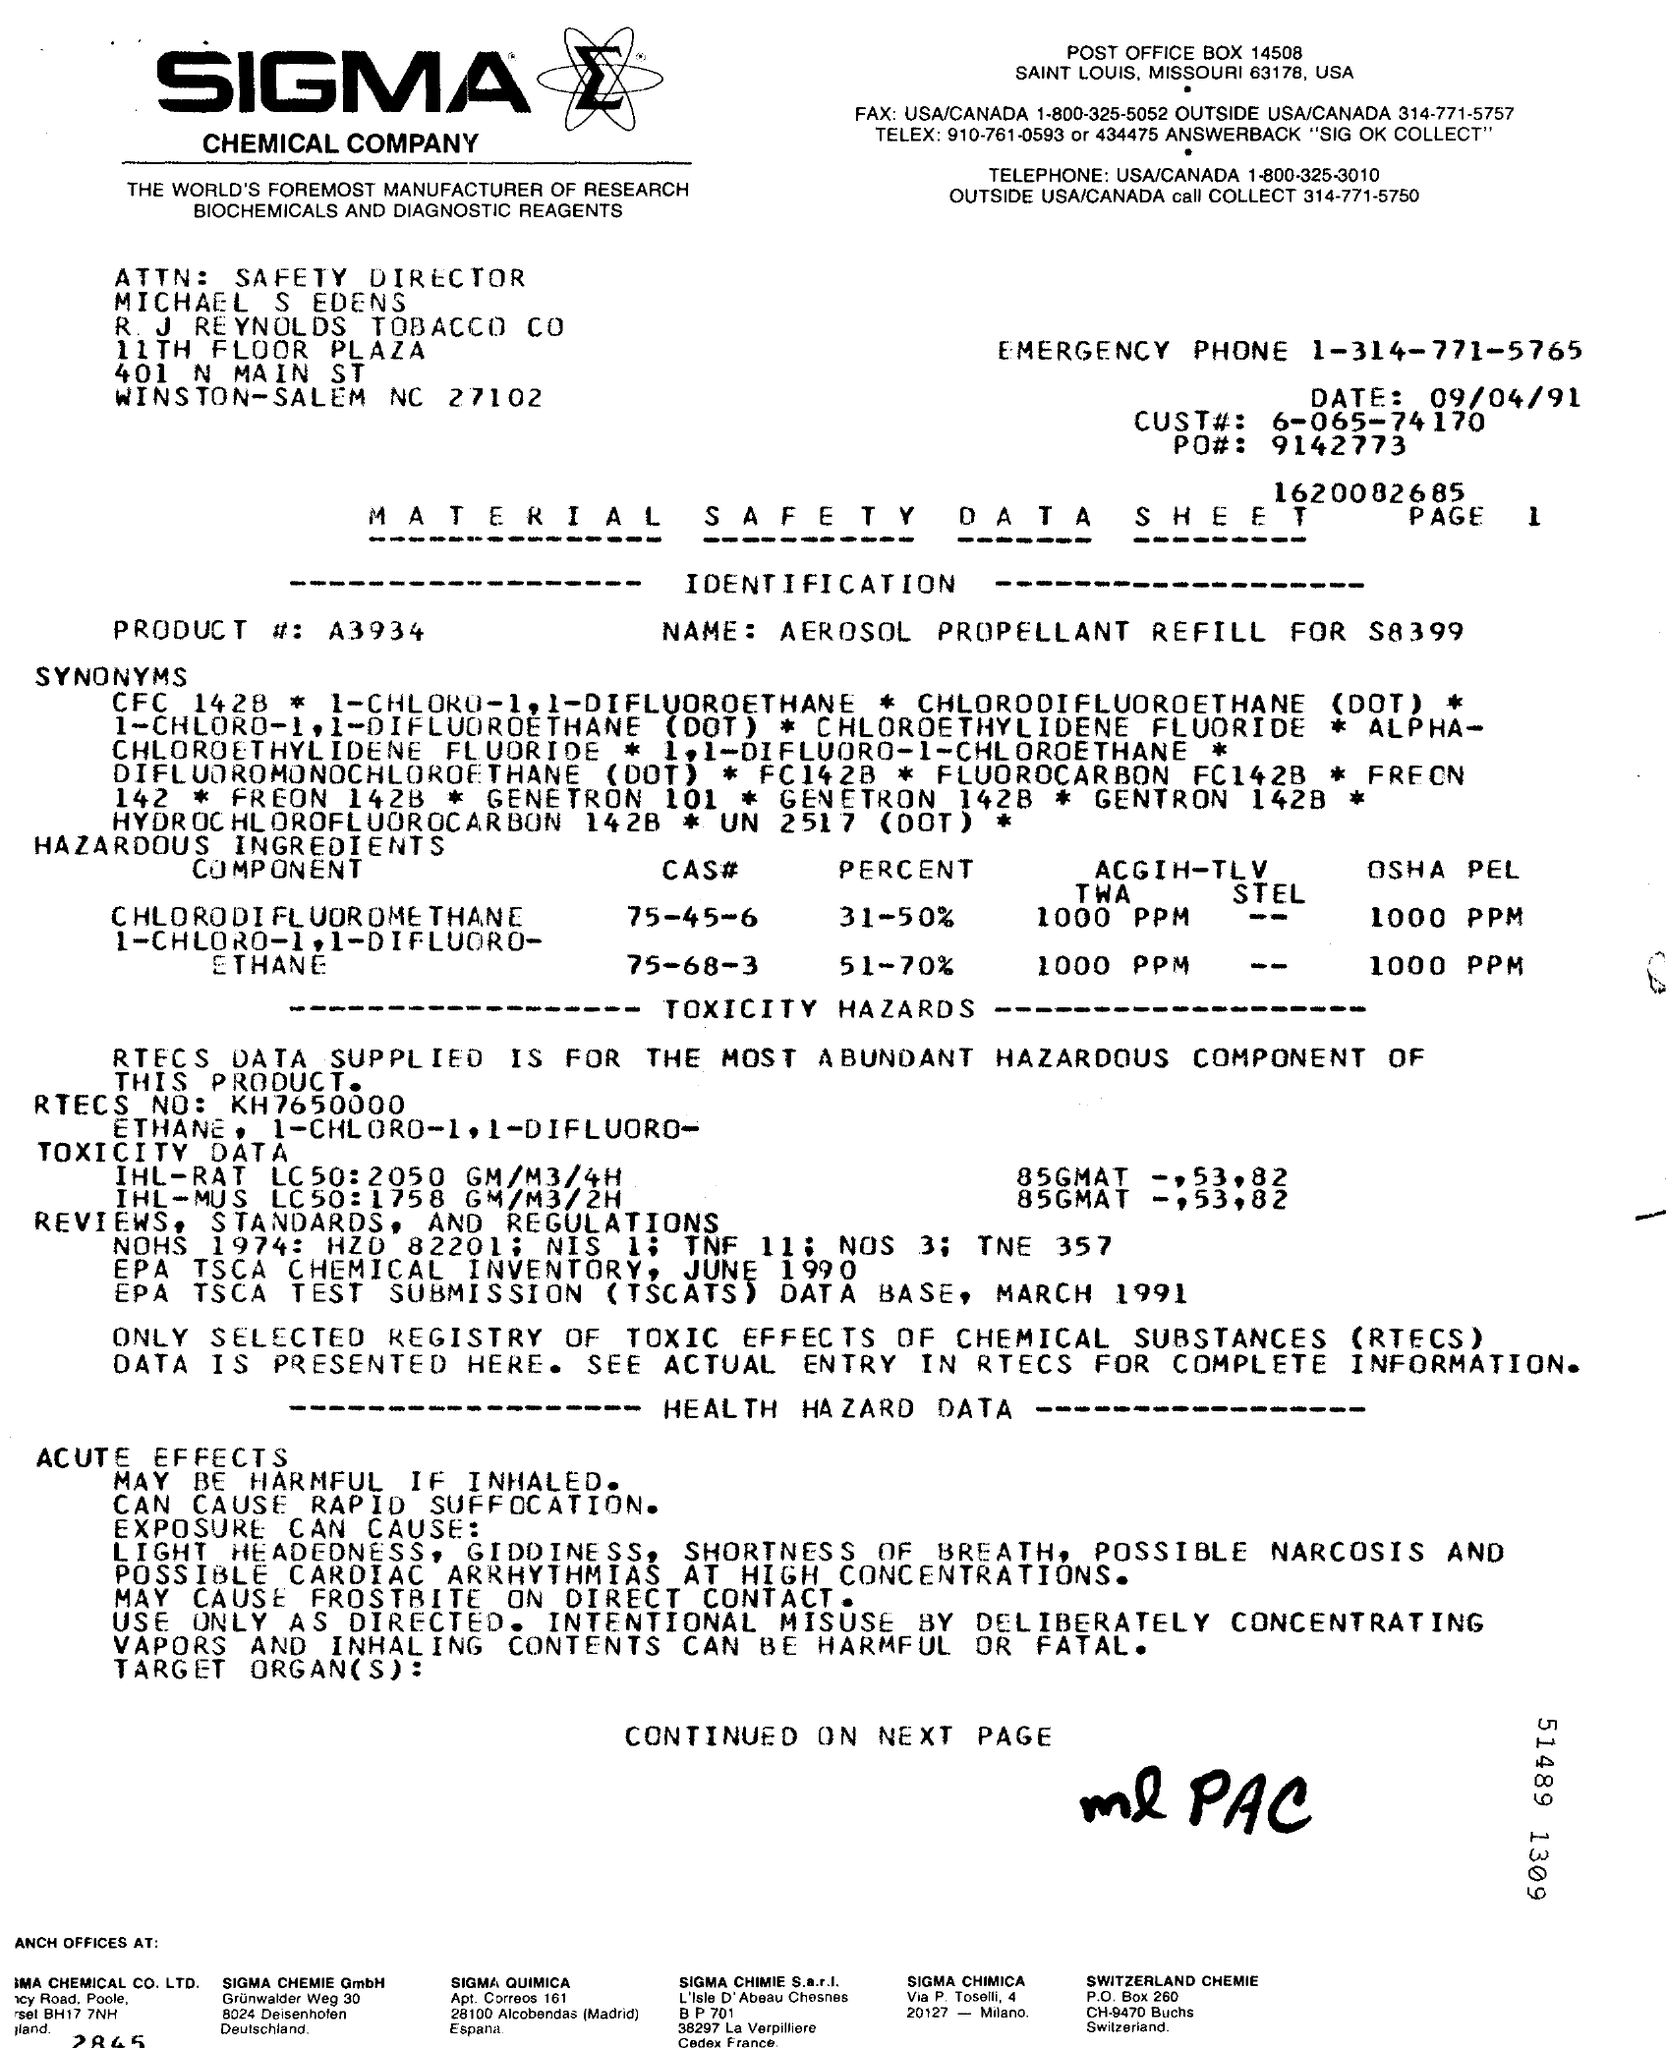Highlight a few significant elements in this photo. The post office box number is 14508. The product number is A3934... The date mentioned is 09/04/91. The page number mentioned in this text is 1.. The FAX number for USA and Canada is 1-800-325-5052. 